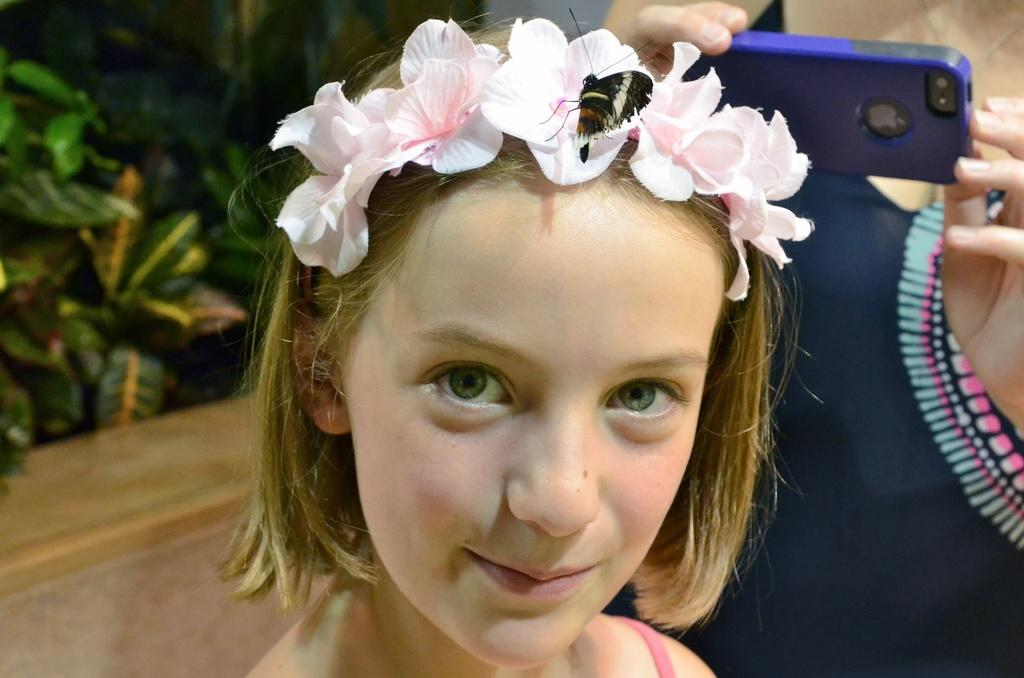Who is the main subject in the foreground of the picture? There is a girl in the foreground of the picture. What is on the girl's head? The girl has flowers on her head. What can be seen near the girl? There is a butterfly near the girl. What is the person on the right side of the picture holding? The person is holding a mobile on the right side of the picture. What type of vegetation is on the left side of the picture? There are plants on the left side of the picture. What type of jeans is the girl wearing in the image? There is no mention of jeans in the image, as the girl has a dress or skirt on, with flowers on her head. Can you see a nest in the image? There is no nest present in the image. 